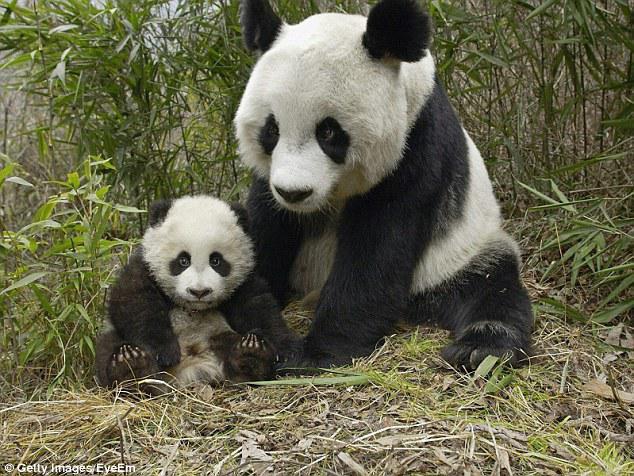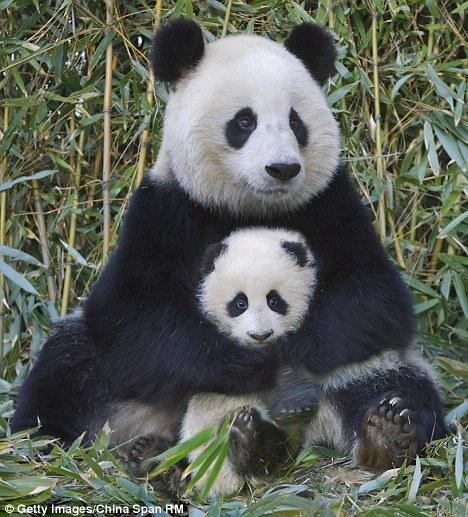The first image is the image on the left, the second image is the image on the right. Assess this claim about the two images: "There are four pandas.". Correct or not? Answer yes or no. Yes. The first image is the image on the left, the second image is the image on the right. Evaluate the accuracy of this statement regarding the images: "There are four pandas.". Is it true? Answer yes or no. Yes. 